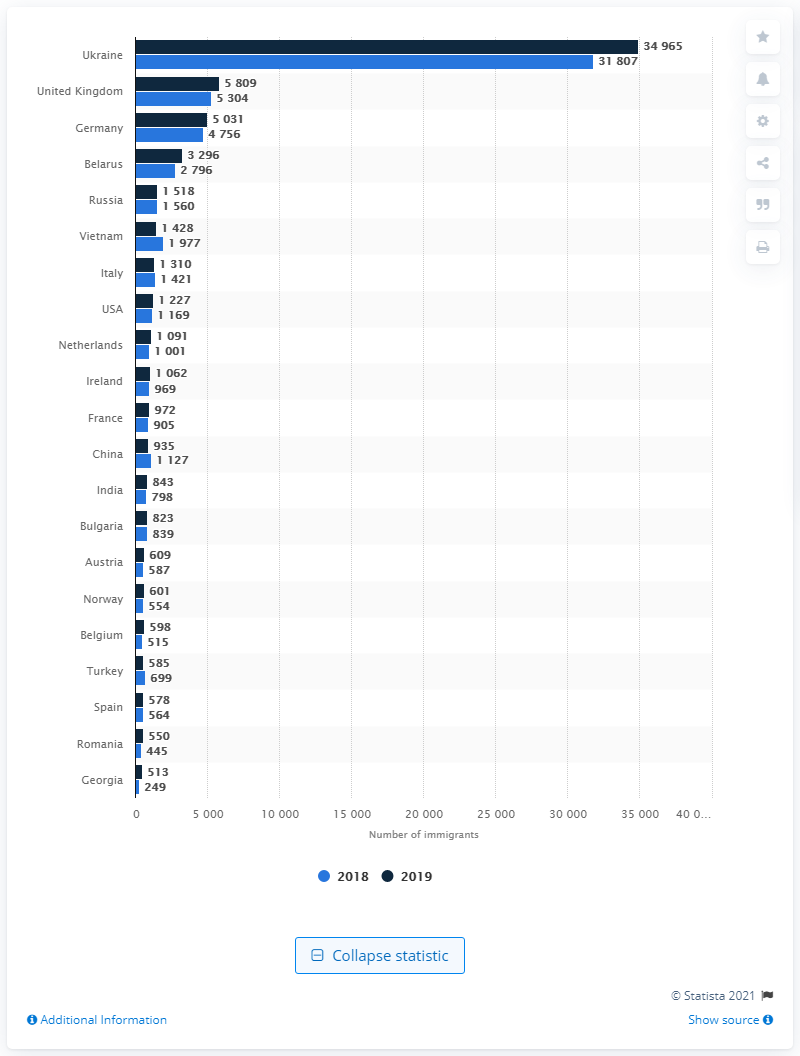Point out several critical features in this image. In 2019, the country with the largest number of immigrants in Poland was Ukraine. In 2019, the largest number of immigrants in Poland came from Ukraine. 